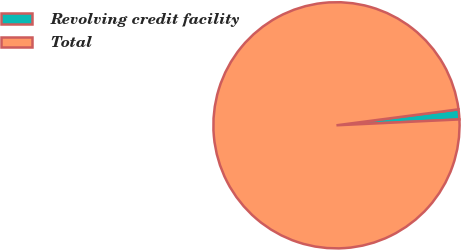<chart> <loc_0><loc_0><loc_500><loc_500><pie_chart><fcel>Revolving credit facility<fcel>Total<nl><fcel>1.31%<fcel>98.69%<nl></chart> 